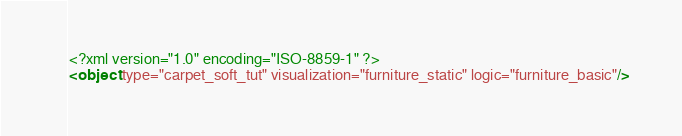Convert code to text. <code><loc_0><loc_0><loc_500><loc_500><_XML_><?xml version="1.0" encoding="ISO-8859-1" ?>
<object type="carpet_soft_tut" visualization="furniture_static" logic="furniture_basic"/>
</code> 